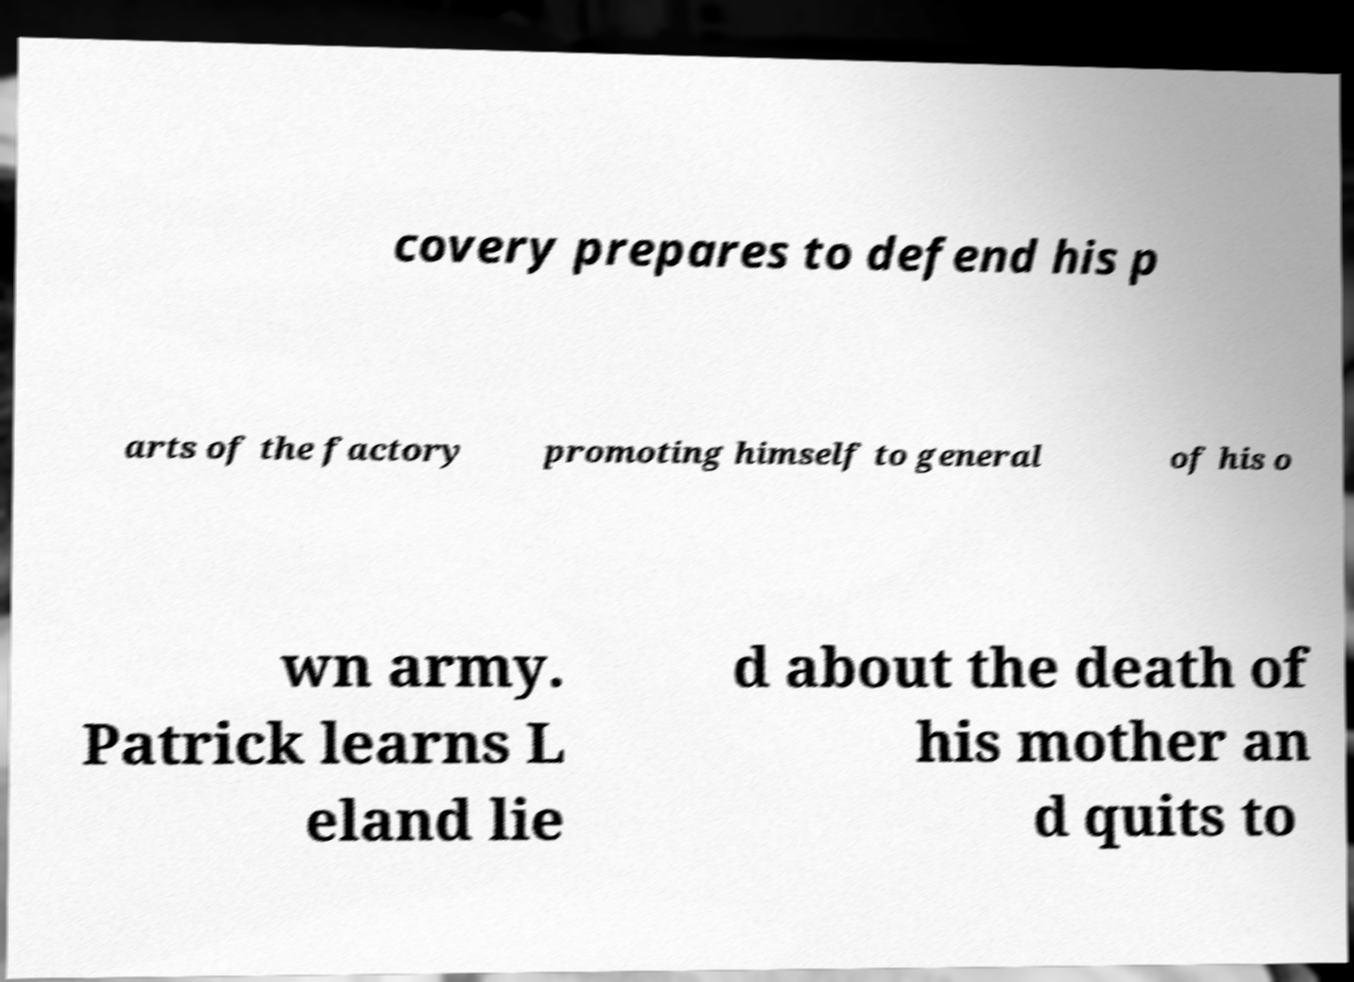Please read and relay the text visible in this image. What does it say? covery prepares to defend his p arts of the factory promoting himself to general of his o wn army. Patrick learns L eland lie d about the death of his mother an d quits to 